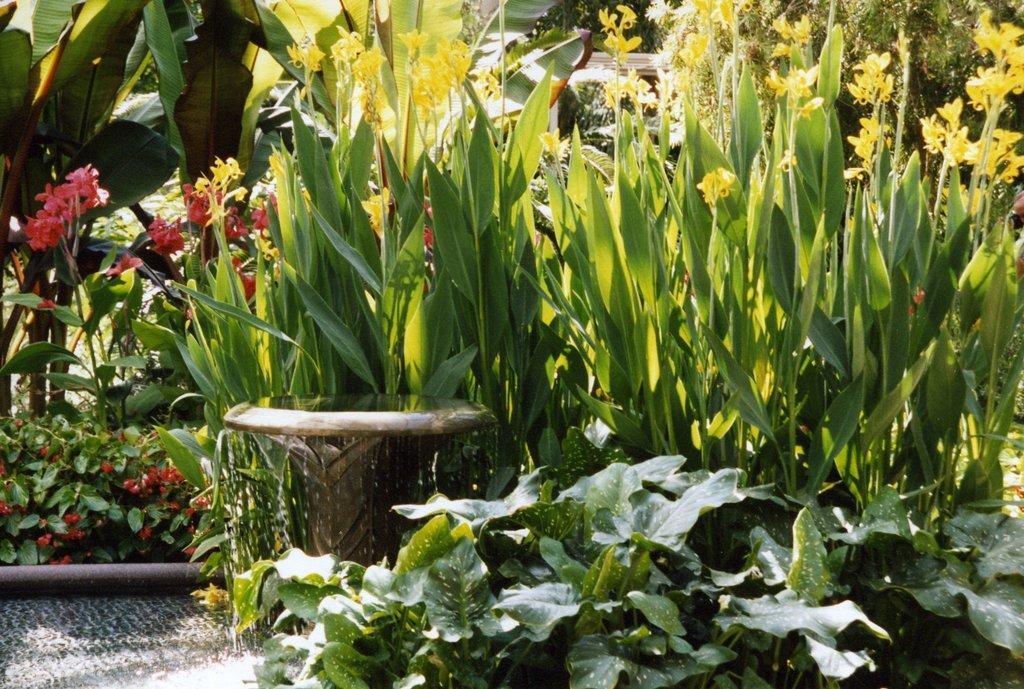Describe this image in one or two sentences. In this image I can see few plants and few flowers which are red in color and few other flowers which are yellow in color. I can see a brown colored pipe and a brown colored object from which I can see few water drops are falling on the floor. 